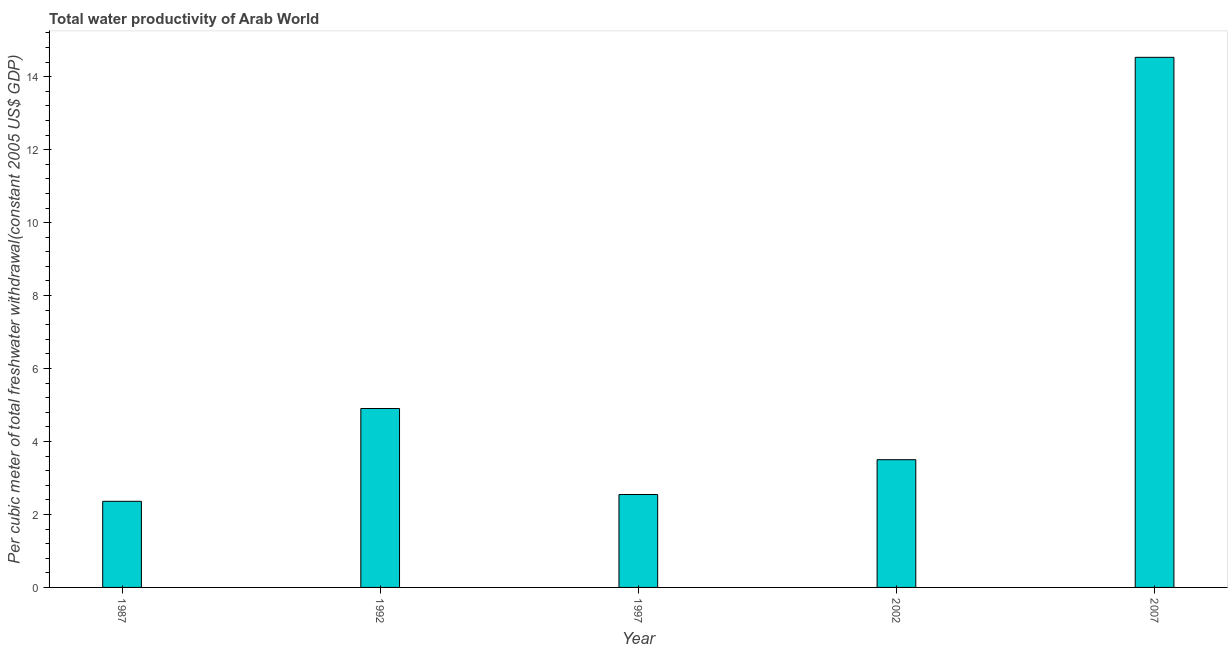Does the graph contain any zero values?
Your answer should be very brief. No. What is the title of the graph?
Offer a very short reply. Total water productivity of Arab World. What is the label or title of the Y-axis?
Provide a succinct answer. Per cubic meter of total freshwater withdrawal(constant 2005 US$ GDP). What is the total water productivity in 1992?
Provide a short and direct response. 4.9. Across all years, what is the maximum total water productivity?
Provide a succinct answer. 14.53. Across all years, what is the minimum total water productivity?
Offer a very short reply. 2.36. In which year was the total water productivity maximum?
Ensure brevity in your answer.  2007. In which year was the total water productivity minimum?
Provide a short and direct response. 1987. What is the sum of the total water productivity?
Make the answer very short. 27.84. What is the difference between the total water productivity in 1987 and 1997?
Offer a very short reply. -0.19. What is the average total water productivity per year?
Offer a terse response. 5.57. What is the median total water productivity?
Your answer should be compact. 3.5. In how many years, is the total water productivity greater than 12 US$?
Provide a short and direct response. 1. Do a majority of the years between 1987 and 1992 (inclusive) have total water productivity greater than 4.4 US$?
Offer a terse response. No. What is the ratio of the total water productivity in 1987 to that in 1992?
Offer a very short reply. 0.48. Is the total water productivity in 1992 less than that in 1997?
Your response must be concise. No. Is the difference between the total water productivity in 1992 and 2007 greater than the difference between any two years?
Offer a very short reply. No. What is the difference between the highest and the second highest total water productivity?
Make the answer very short. 9.63. Is the sum of the total water productivity in 1987 and 2007 greater than the maximum total water productivity across all years?
Provide a succinct answer. Yes. What is the difference between the highest and the lowest total water productivity?
Ensure brevity in your answer.  12.17. How many bars are there?
Provide a succinct answer. 5. How many years are there in the graph?
Ensure brevity in your answer.  5. What is the Per cubic meter of total freshwater withdrawal(constant 2005 US$ GDP) of 1987?
Make the answer very short. 2.36. What is the Per cubic meter of total freshwater withdrawal(constant 2005 US$ GDP) in 1992?
Offer a terse response. 4.9. What is the Per cubic meter of total freshwater withdrawal(constant 2005 US$ GDP) in 1997?
Ensure brevity in your answer.  2.55. What is the Per cubic meter of total freshwater withdrawal(constant 2005 US$ GDP) of 2002?
Provide a succinct answer. 3.5. What is the Per cubic meter of total freshwater withdrawal(constant 2005 US$ GDP) in 2007?
Your answer should be compact. 14.53. What is the difference between the Per cubic meter of total freshwater withdrawal(constant 2005 US$ GDP) in 1987 and 1992?
Keep it short and to the point. -2.54. What is the difference between the Per cubic meter of total freshwater withdrawal(constant 2005 US$ GDP) in 1987 and 1997?
Provide a short and direct response. -0.19. What is the difference between the Per cubic meter of total freshwater withdrawal(constant 2005 US$ GDP) in 1987 and 2002?
Provide a succinct answer. -1.14. What is the difference between the Per cubic meter of total freshwater withdrawal(constant 2005 US$ GDP) in 1987 and 2007?
Your answer should be compact. -12.17. What is the difference between the Per cubic meter of total freshwater withdrawal(constant 2005 US$ GDP) in 1992 and 1997?
Your answer should be compact. 2.36. What is the difference between the Per cubic meter of total freshwater withdrawal(constant 2005 US$ GDP) in 1992 and 2002?
Offer a terse response. 1.4. What is the difference between the Per cubic meter of total freshwater withdrawal(constant 2005 US$ GDP) in 1992 and 2007?
Your answer should be very brief. -9.63. What is the difference between the Per cubic meter of total freshwater withdrawal(constant 2005 US$ GDP) in 1997 and 2002?
Ensure brevity in your answer.  -0.95. What is the difference between the Per cubic meter of total freshwater withdrawal(constant 2005 US$ GDP) in 1997 and 2007?
Your response must be concise. -11.98. What is the difference between the Per cubic meter of total freshwater withdrawal(constant 2005 US$ GDP) in 2002 and 2007?
Offer a very short reply. -11.03. What is the ratio of the Per cubic meter of total freshwater withdrawal(constant 2005 US$ GDP) in 1987 to that in 1992?
Ensure brevity in your answer.  0.48. What is the ratio of the Per cubic meter of total freshwater withdrawal(constant 2005 US$ GDP) in 1987 to that in 1997?
Give a very brief answer. 0.93. What is the ratio of the Per cubic meter of total freshwater withdrawal(constant 2005 US$ GDP) in 1987 to that in 2002?
Ensure brevity in your answer.  0.67. What is the ratio of the Per cubic meter of total freshwater withdrawal(constant 2005 US$ GDP) in 1987 to that in 2007?
Your answer should be very brief. 0.16. What is the ratio of the Per cubic meter of total freshwater withdrawal(constant 2005 US$ GDP) in 1992 to that in 1997?
Provide a short and direct response. 1.93. What is the ratio of the Per cubic meter of total freshwater withdrawal(constant 2005 US$ GDP) in 1992 to that in 2002?
Give a very brief answer. 1.4. What is the ratio of the Per cubic meter of total freshwater withdrawal(constant 2005 US$ GDP) in 1992 to that in 2007?
Provide a short and direct response. 0.34. What is the ratio of the Per cubic meter of total freshwater withdrawal(constant 2005 US$ GDP) in 1997 to that in 2002?
Offer a very short reply. 0.73. What is the ratio of the Per cubic meter of total freshwater withdrawal(constant 2005 US$ GDP) in 1997 to that in 2007?
Your answer should be very brief. 0.17. What is the ratio of the Per cubic meter of total freshwater withdrawal(constant 2005 US$ GDP) in 2002 to that in 2007?
Provide a short and direct response. 0.24. 